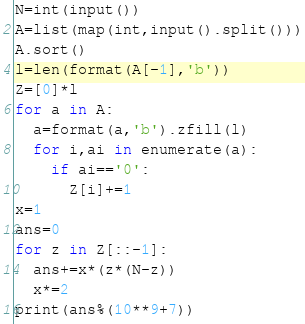Convert code to text. <code><loc_0><loc_0><loc_500><loc_500><_Python_>N=int(input())
A=list(map(int,input().split()))
A.sort()
l=len(format(A[-1],'b'))
Z=[0]*l
for a in A:
  a=format(a,'b').zfill(l)
  for i,ai in enumerate(a):
    if ai=='0':
      Z[i]+=1
x=1
ans=0
for z in Z[::-1]:
  ans+=x*(z*(N-z))
  x*=2
print(ans%(10**9+7))</code> 